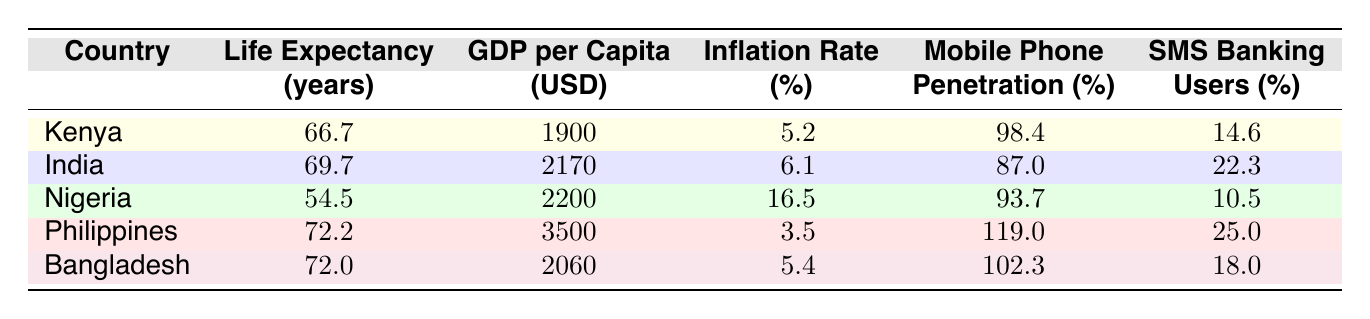What is the life expectancy of Kenya? From the table, we can directly look under the "Life Expectancy" column for Kenya, which clearly shows a value of 66.7 years.
Answer: 66.7 Which country has the highest GDP per capita? By examining the "GDP per Capita" column, we can identify that the Philippines has the highest value listed, which is 3500 USD.
Answer: Philippines What is the difference in life expectancy between India and Nigeria? The life expectancy for India is 69.7 years and for Nigeria, it is 54.5 years. We subtract Nigeria's life expectancy from India's: 69.7 - 54.5 = 15.2 years.
Answer: 15.2 Does Kenya have a higher mobile phone penetration rate than India? Looking at the "Mobile Phone Penetration" column, Kenya has 98.4% while India has 87.0%. Since 98.4% is greater than 87.0%, the statement is true.
Answer: Yes What is the average inflation rate of the five countries listed? To find the average, we sum the inflation rates: 5.2 + 6.1 + 16.5 + 3.5 + 5.4 = 36.7. There are five countries, so we divide the total by 5: 36.7 / 5 = 7.34%.
Answer: 7.34 Which country has the highest percentage of SMS banking users? From the "SMS Banking" column, the Philippines has the highest percentage listed at 25.0%, compared to others listed in the table.
Answer: Philippines If Nigeria improves its mobile phone penetration to match Kenya's, how much would be the difference in SMS banking users? Currently, Nigeria has 10.5% SMS banking users and if it matches Kenya's mobile phone penetration of 98.4%, we check if there could be any impact on SMS banking user percentage; however, the question does not state that the user percentage will change. Hence, the difference remains the same: 10.5%.
Answer: 10.5 Is life expectancy positively correlated with GDP per capita in this table? If we analyze: Kenya (66.7, 1900), India (69.7, 2170), Nigeria (54.5, 2200), Philippines (72.2, 3500) and Bangladesh (72.0, 2060). Life expectancy tends to increase with higher GDP per capita, showing a positive correlation overall, despite Nigeria's lower expectancy with a higher GDP compared to Kenya.
Answer: Yes What is the percentage of SMS banking users in Bangladesh? Referring to the "SMS Banking" column, Bangladesh has a percentage of 18.0% for SMS banking users, which is clearly listed.
Answer: 18.0 